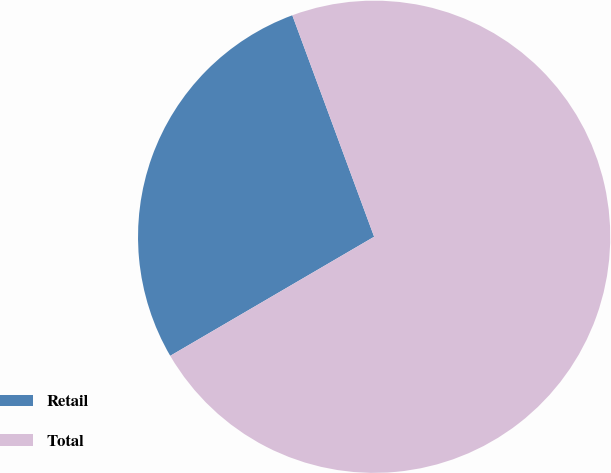<chart> <loc_0><loc_0><loc_500><loc_500><pie_chart><fcel>Retail<fcel>Total<nl><fcel>27.78%<fcel>72.22%<nl></chart> 